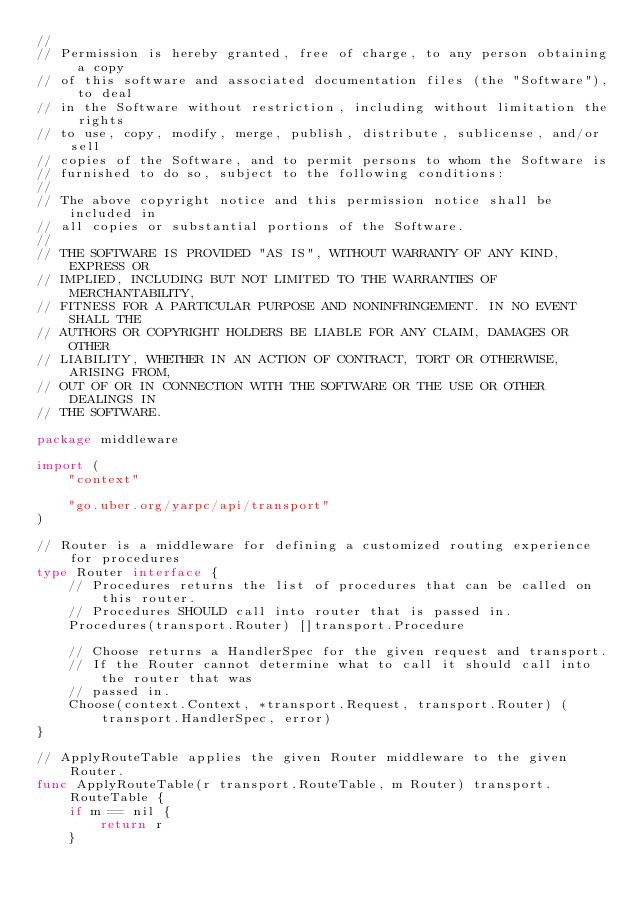Convert code to text. <code><loc_0><loc_0><loc_500><loc_500><_Go_>//
// Permission is hereby granted, free of charge, to any person obtaining a copy
// of this software and associated documentation files (the "Software"), to deal
// in the Software without restriction, including without limitation the rights
// to use, copy, modify, merge, publish, distribute, sublicense, and/or sell
// copies of the Software, and to permit persons to whom the Software is
// furnished to do so, subject to the following conditions:
//
// The above copyright notice and this permission notice shall be included in
// all copies or substantial portions of the Software.
//
// THE SOFTWARE IS PROVIDED "AS IS", WITHOUT WARRANTY OF ANY KIND, EXPRESS OR
// IMPLIED, INCLUDING BUT NOT LIMITED TO THE WARRANTIES OF MERCHANTABILITY,
// FITNESS FOR A PARTICULAR PURPOSE AND NONINFRINGEMENT. IN NO EVENT SHALL THE
// AUTHORS OR COPYRIGHT HOLDERS BE LIABLE FOR ANY CLAIM, DAMAGES OR OTHER
// LIABILITY, WHETHER IN AN ACTION OF CONTRACT, TORT OR OTHERWISE, ARISING FROM,
// OUT OF OR IN CONNECTION WITH THE SOFTWARE OR THE USE OR OTHER DEALINGS IN
// THE SOFTWARE.

package middleware

import (
	"context"

	"go.uber.org/yarpc/api/transport"
)

// Router is a middleware for defining a customized routing experience for procedures
type Router interface {
	// Procedures returns the list of procedures that can be called on this router.
	// Procedures SHOULD call into router that is passed in.
	Procedures(transport.Router) []transport.Procedure

	// Choose returns a HandlerSpec for the given request and transport.
	// If the Router cannot determine what to call it should call into the router that was
	// passed in.
	Choose(context.Context, *transport.Request, transport.Router) (transport.HandlerSpec, error)
}

// ApplyRouteTable applies the given Router middleware to the given Router.
func ApplyRouteTable(r transport.RouteTable, m Router) transport.RouteTable {
	if m == nil {
		return r
	}</code> 